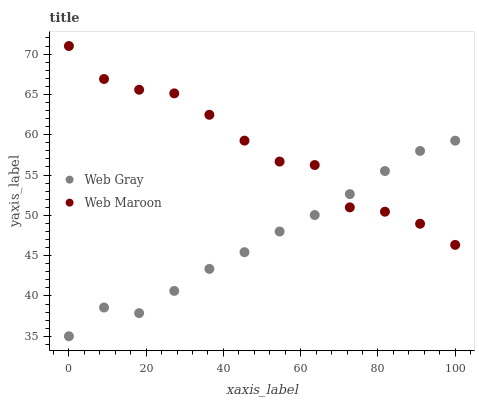Does Web Gray have the minimum area under the curve?
Answer yes or no. Yes. Does Web Maroon have the maximum area under the curve?
Answer yes or no. Yes. Does Web Maroon have the minimum area under the curve?
Answer yes or no. No. Is Web Gray the smoothest?
Answer yes or no. Yes. Is Web Maroon the roughest?
Answer yes or no. Yes. Is Web Maroon the smoothest?
Answer yes or no. No. Does Web Gray have the lowest value?
Answer yes or no. Yes. Does Web Maroon have the lowest value?
Answer yes or no. No. Does Web Maroon have the highest value?
Answer yes or no. Yes. Does Web Gray intersect Web Maroon?
Answer yes or no. Yes. Is Web Gray less than Web Maroon?
Answer yes or no. No. Is Web Gray greater than Web Maroon?
Answer yes or no. No. 